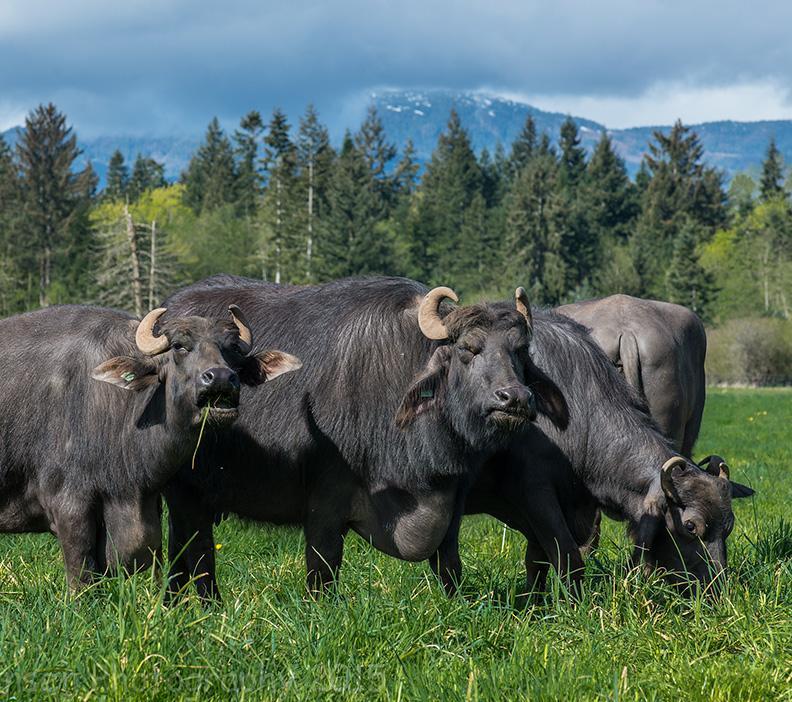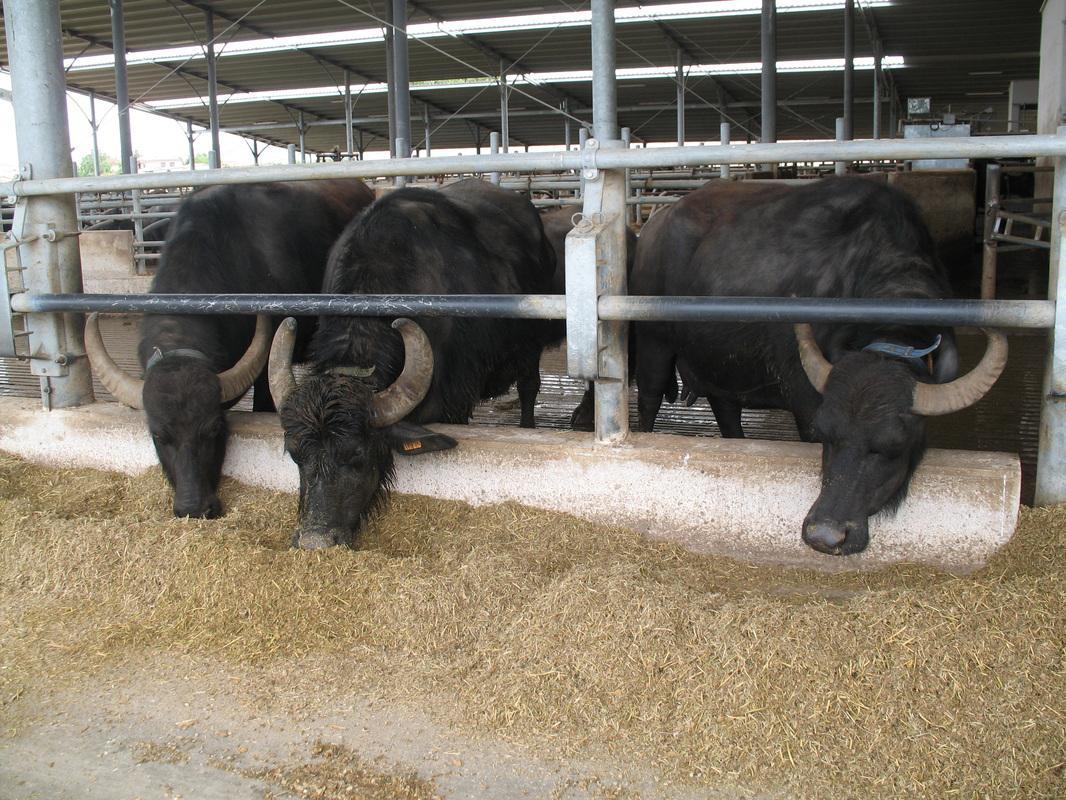The first image is the image on the left, the second image is the image on the right. Evaluate the accuracy of this statement regarding the images: "Some water buffalos are in the water.". Is it true? Answer yes or no. No. The first image is the image on the left, the second image is the image on the right. Evaluate the accuracy of this statement regarding the images: "At least one image includes a water buffalo in chin-deep water, and the left image includes water buffalo and green grass.". Is it true? Answer yes or no. No. 